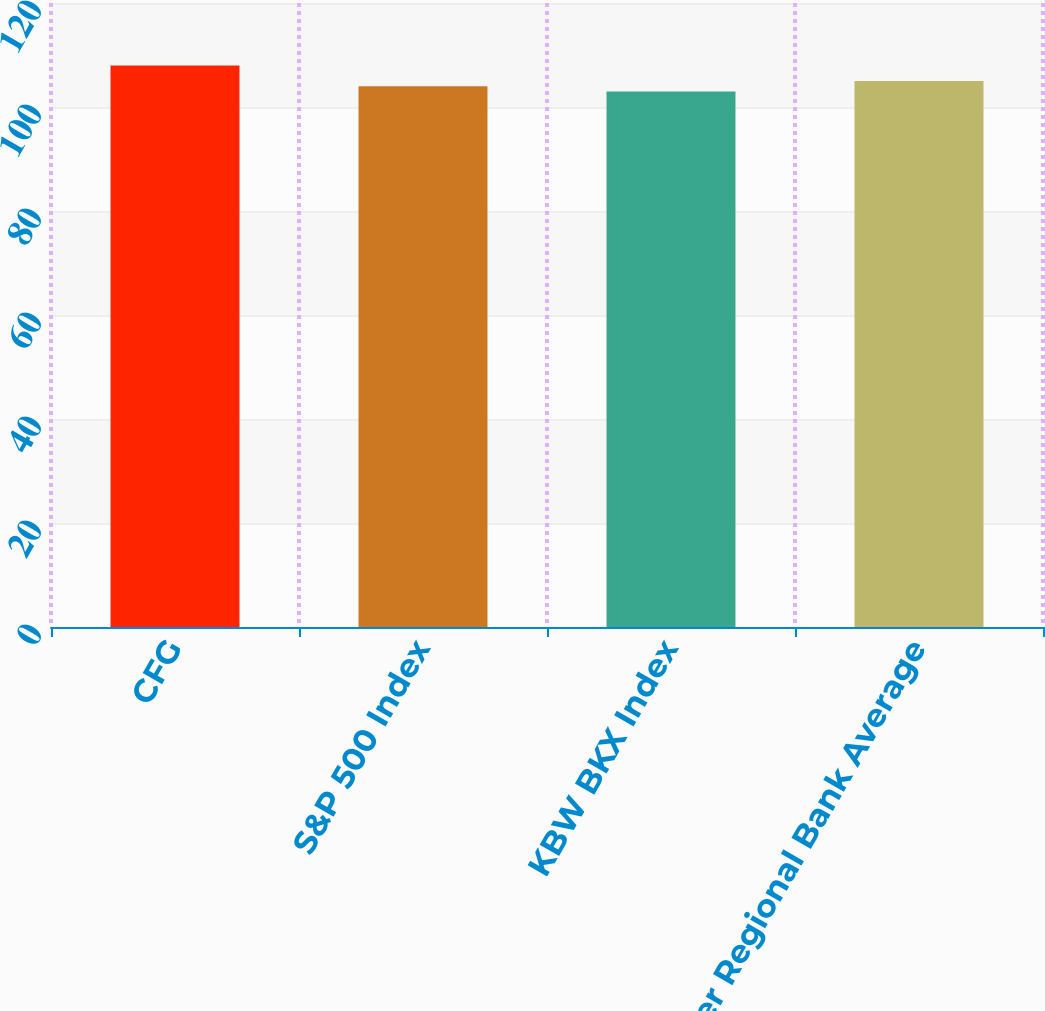Convert chart to OTSL. <chart><loc_0><loc_0><loc_500><loc_500><bar_chart><fcel>CFG<fcel>S&P 500 Index<fcel>KBW BKX Index<fcel>Peer Regional Bank Average<nl><fcel>108<fcel>104<fcel>103<fcel>105<nl></chart> 